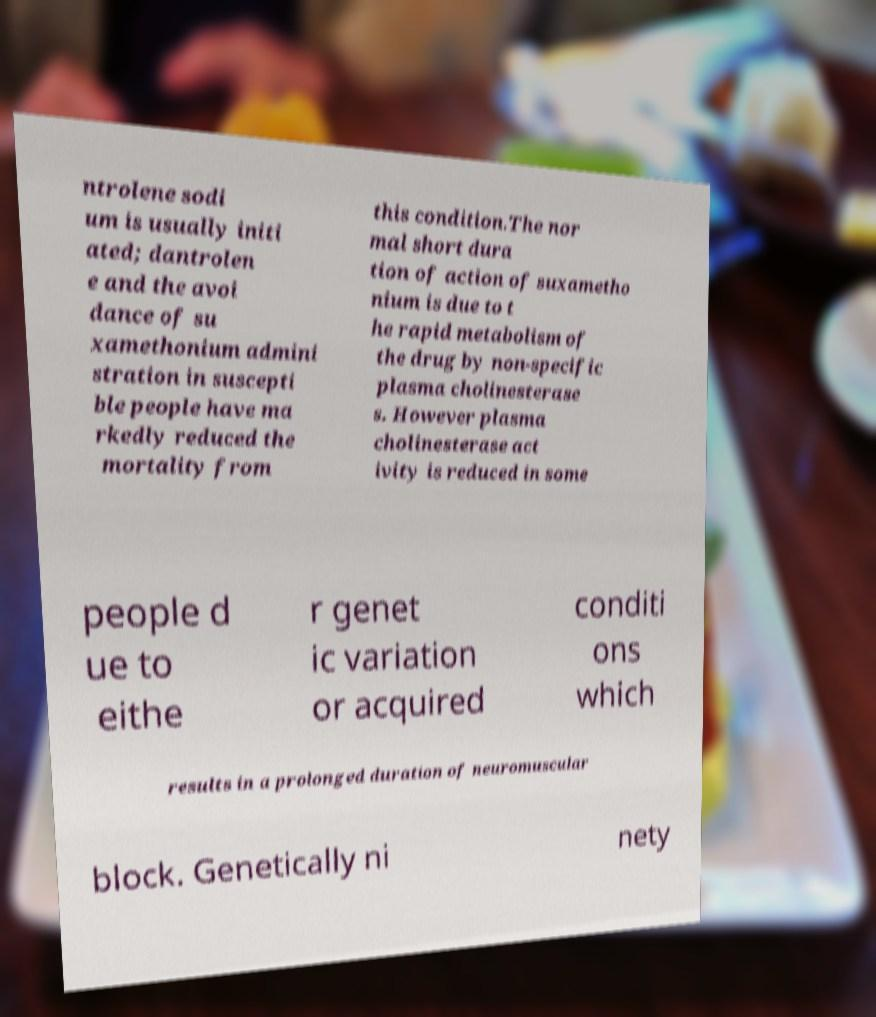I need the written content from this picture converted into text. Can you do that? ntrolene sodi um is usually initi ated; dantrolen e and the avoi dance of su xamethonium admini stration in suscepti ble people have ma rkedly reduced the mortality from this condition.The nor mal short dura tion of action of suxametho nium is due to t he rapid metabolism of the drug by non-specific plasma cholinesterase s. However plasma cholinesterase act ivity is reduced in some people d ue to eithe r genet ic variation or acquired conditi ons which results in a prolonged duration of neuromuscular block. Genetically ni nety 